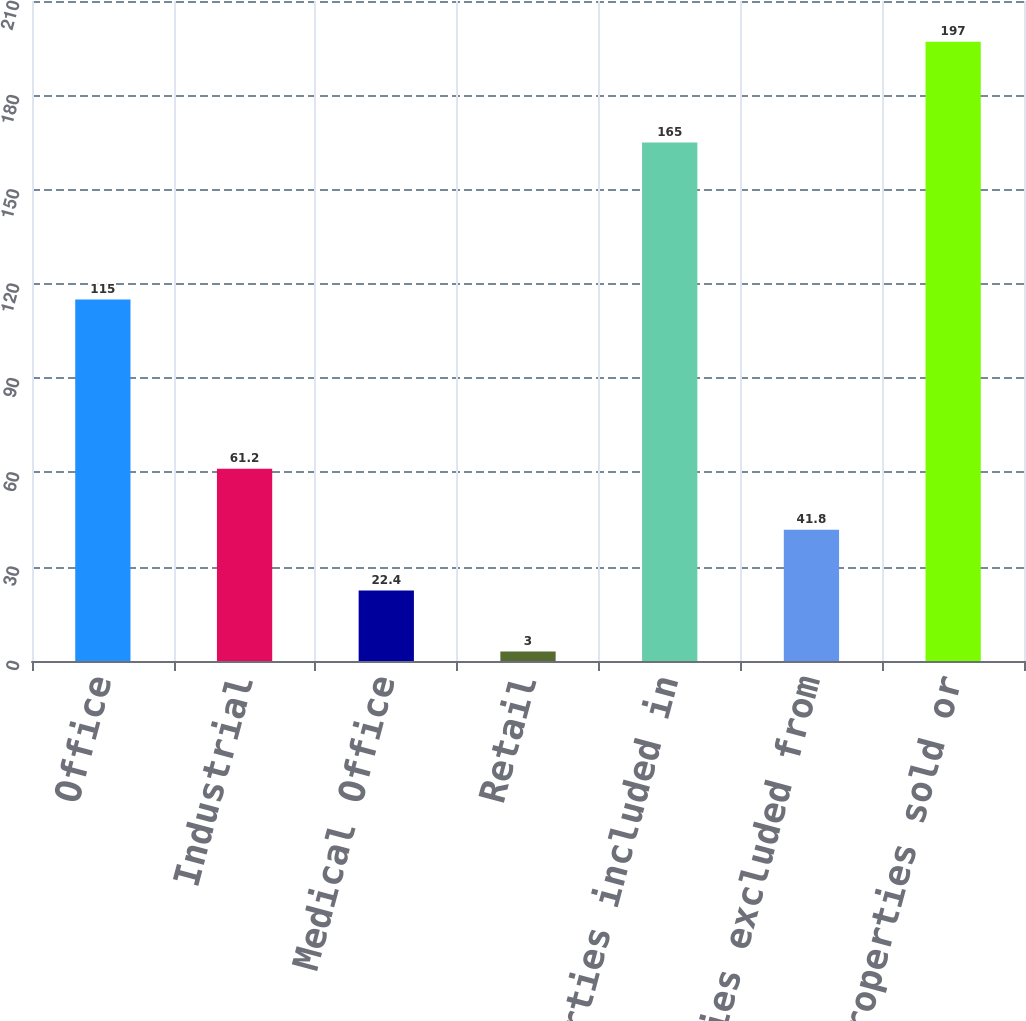<chart> <loc_0><loc_0><loc_500><loc_500><bar_chart><fcel>Office<fcel>Industrial<fcel>Medical Office<fcel>Retail<fcel>Total properties included in<fcel>Properties excluded from<fcel>Total properties sold or<nl><fcel>115<fcel>61.2<fcel>22.4<fcel>3<fcel>165<fcel>41.8<fcel>197<nl></chart> 